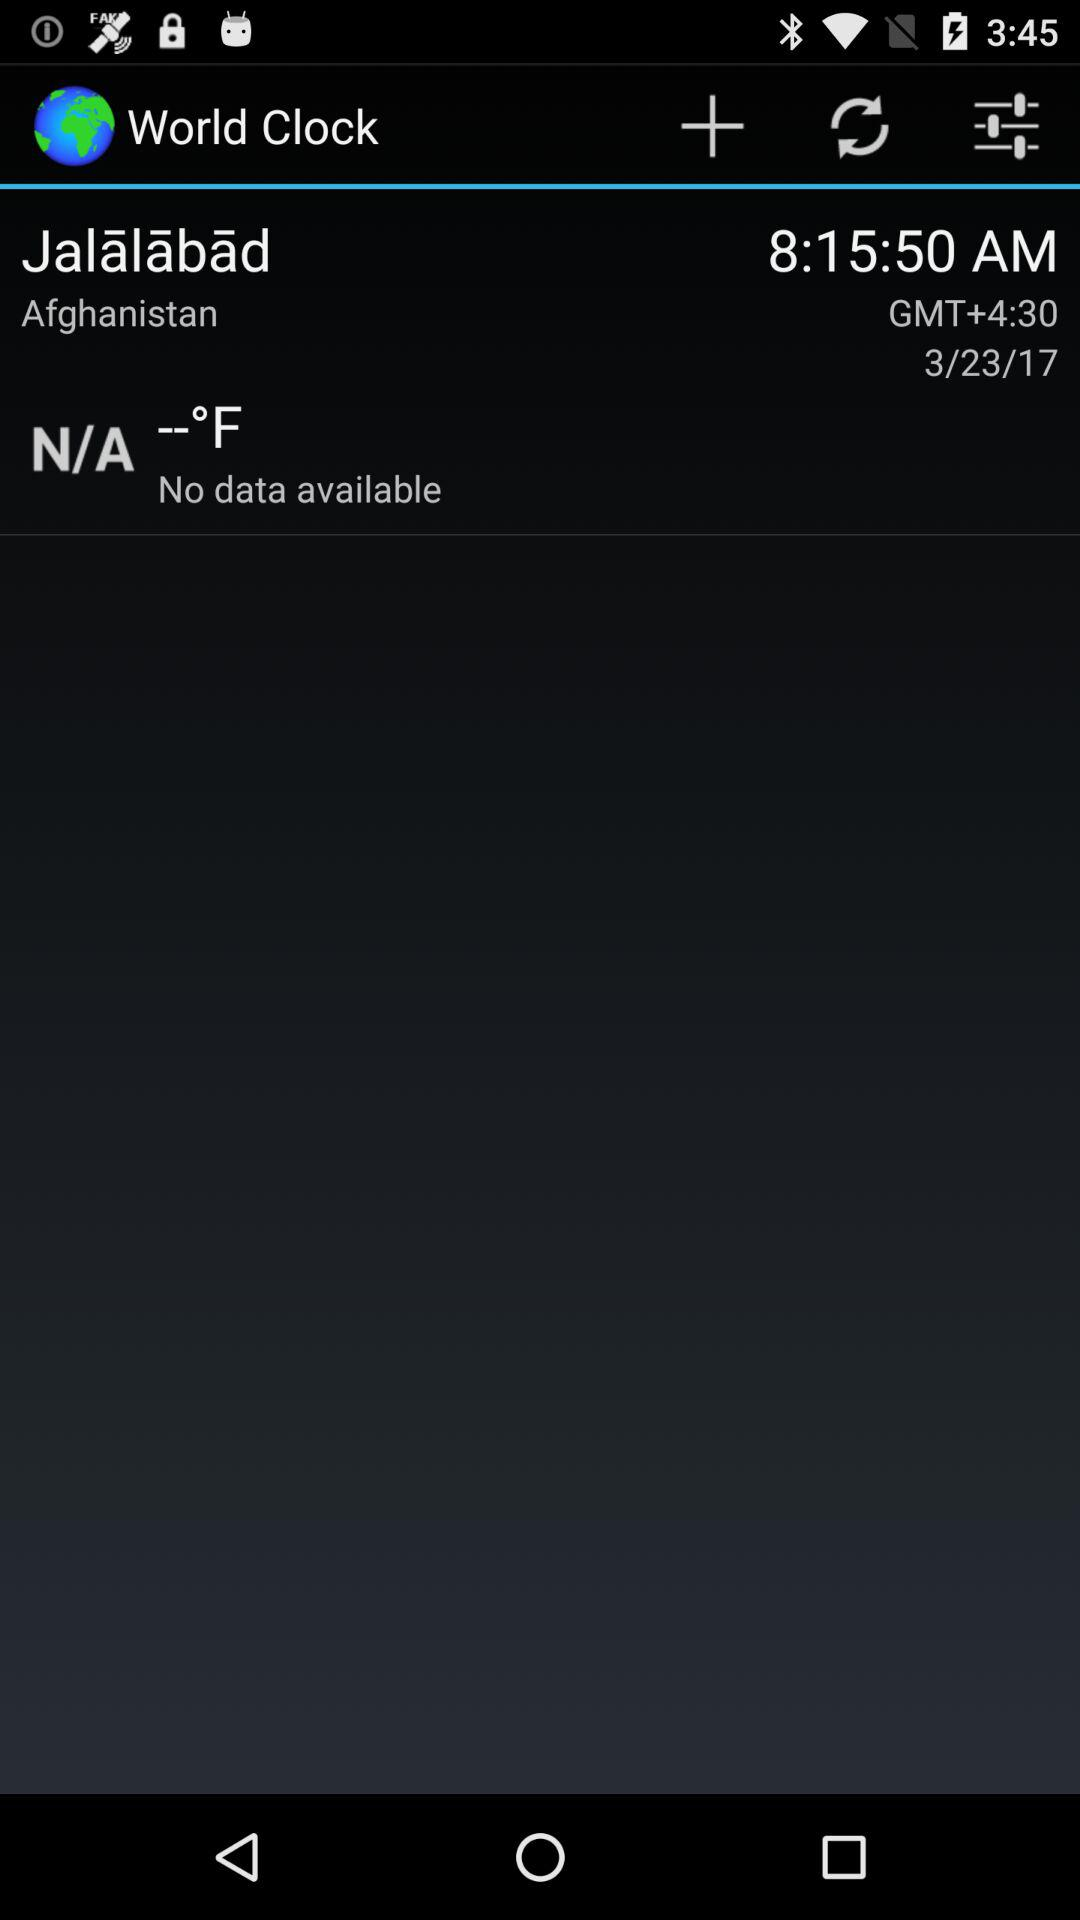What is the time in Afghanistan? The time is 8:15:50 AM GMT+4:30. 